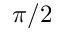Convert formula to latex. <formula><loc_0><loc_0><loc_500><loc_500>\pi / 2</formula> 